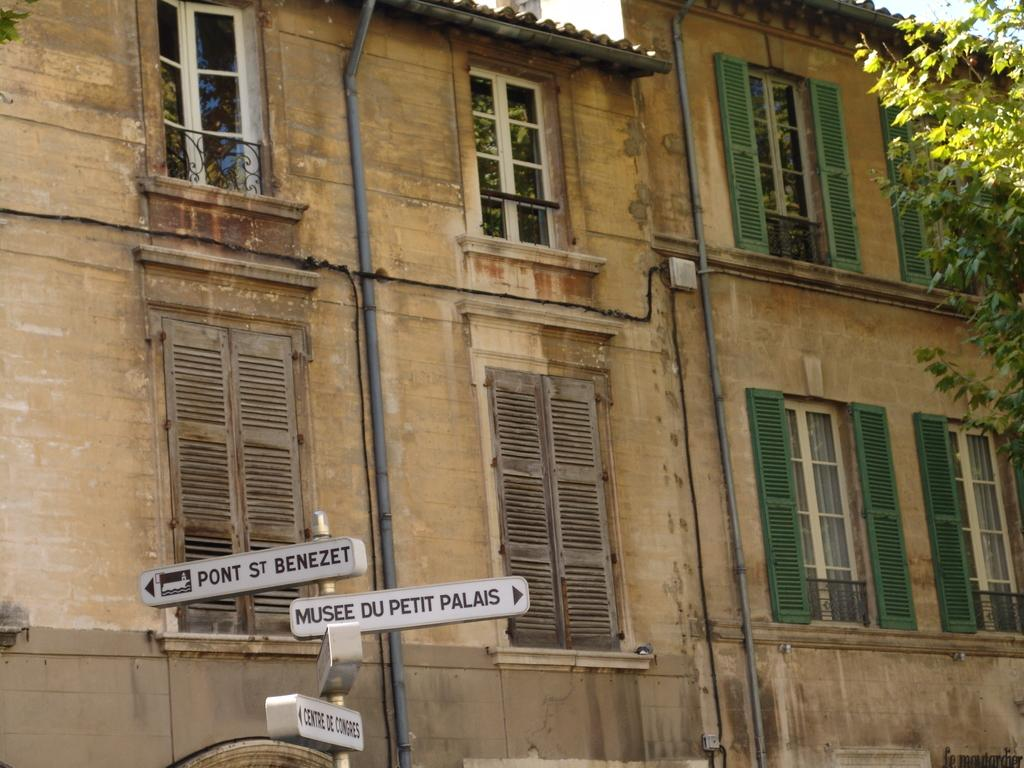What type of structures can be seen in the image? There are buildings in the image. What is located in the foreground of the image? There is a sign board in the foreground of the image. What feature can be observed on the walls of the buildings? There are windows on the wall in the image. What type of vegetation is on the right side of the image? There is a tree on the right side of the image. How many balls are being juggled by the cub in the image? There is no cub or balls present in the image. 